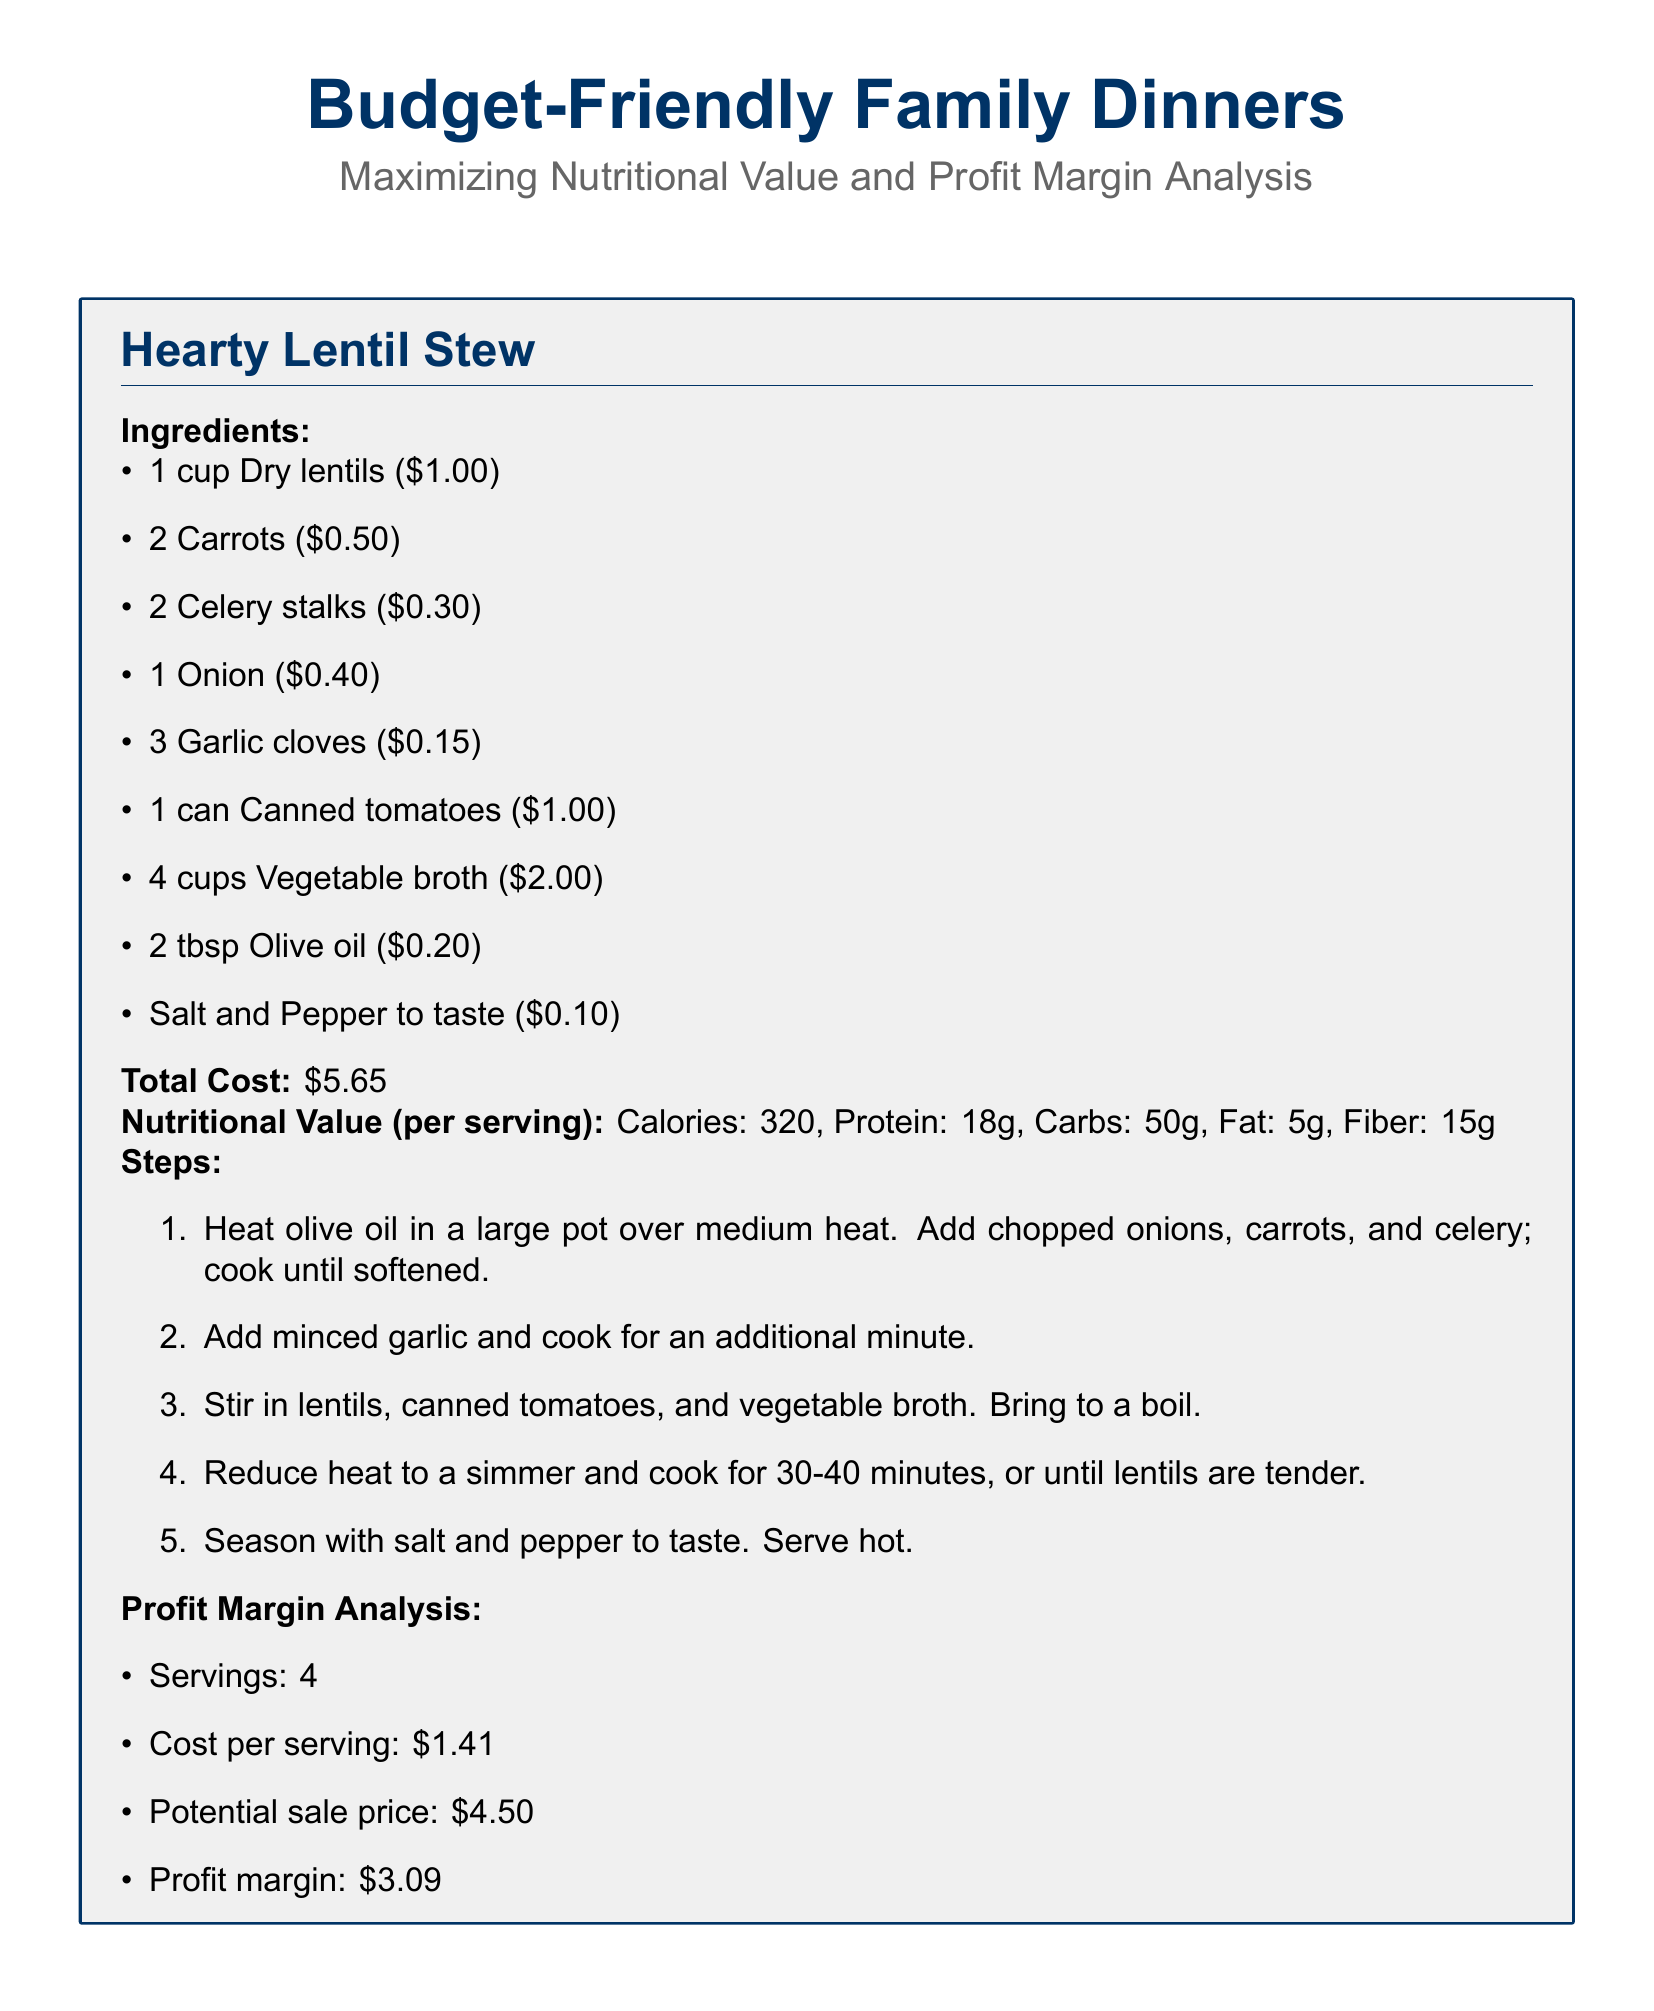what are the main ingredients in the Hearty Lentil Stew? The main ingredients are a cup of dry lentils, two carrots, two celery stalks, one onion, three garlic cloves, one can of canned tomatoes, four cups of vegetable broth, two tablespoons of olive oil, and salt and pepper to taste.
Answer: Dry lentils, carrots, celery, onion, garlic, canned tomatoes, vegetable broth, olive oil, salt and pepper what is the total cost of the Hearty Lentil Stew? The total cost is calculated by adding all individual ingredient costs in the recipe.
Answer: $5.65 how many servings does the Hearty Lentil Stew provide? The number of servings is directly stated in the profit margin analysis section of the recipe.
Answer: 4 what is the profit margin for the Hearty Lentil Stew? The profit margin is determined by subtracting the cost per serving from the potential sale price per serving, which are provided in the profit margin analysis.
Answer: $3.09 what is the calorie count per serving in the Hearty Lentil Stew? The calorie count is given in the nutritional value section of the recipe.
Answer: 320 what is the suggested potential sale price per serving? The suggested price is indicated in the profit margin analysis of the recipe card.
Answer: $4.50 why is it recommended to track ingredient costs? Tracking ingredient costs helps in maintaining accurate profit margins, which is an essential aspect highlighted in the quick tips for CFOs.
Answer: To maintain accurate profit margins how should fresh produce purchasing be optimized? The recommendation is given in the quick tips for CFOs section, which indicates a method to adapt purchases based on market conditions.
Answer: Analyze seasonal price fluctuations what is the purpose of implementing portion control? The role of portion control is explained in the context of ensuring consistency and profitability in the quick tips for CFOs section.
Answer: To ensure consistent servings and profitability how much protein is contained in each serving of the Hearty Lentil Stew? The protein amount is provided under nutritional value in the recipe.
Answer: 18g 